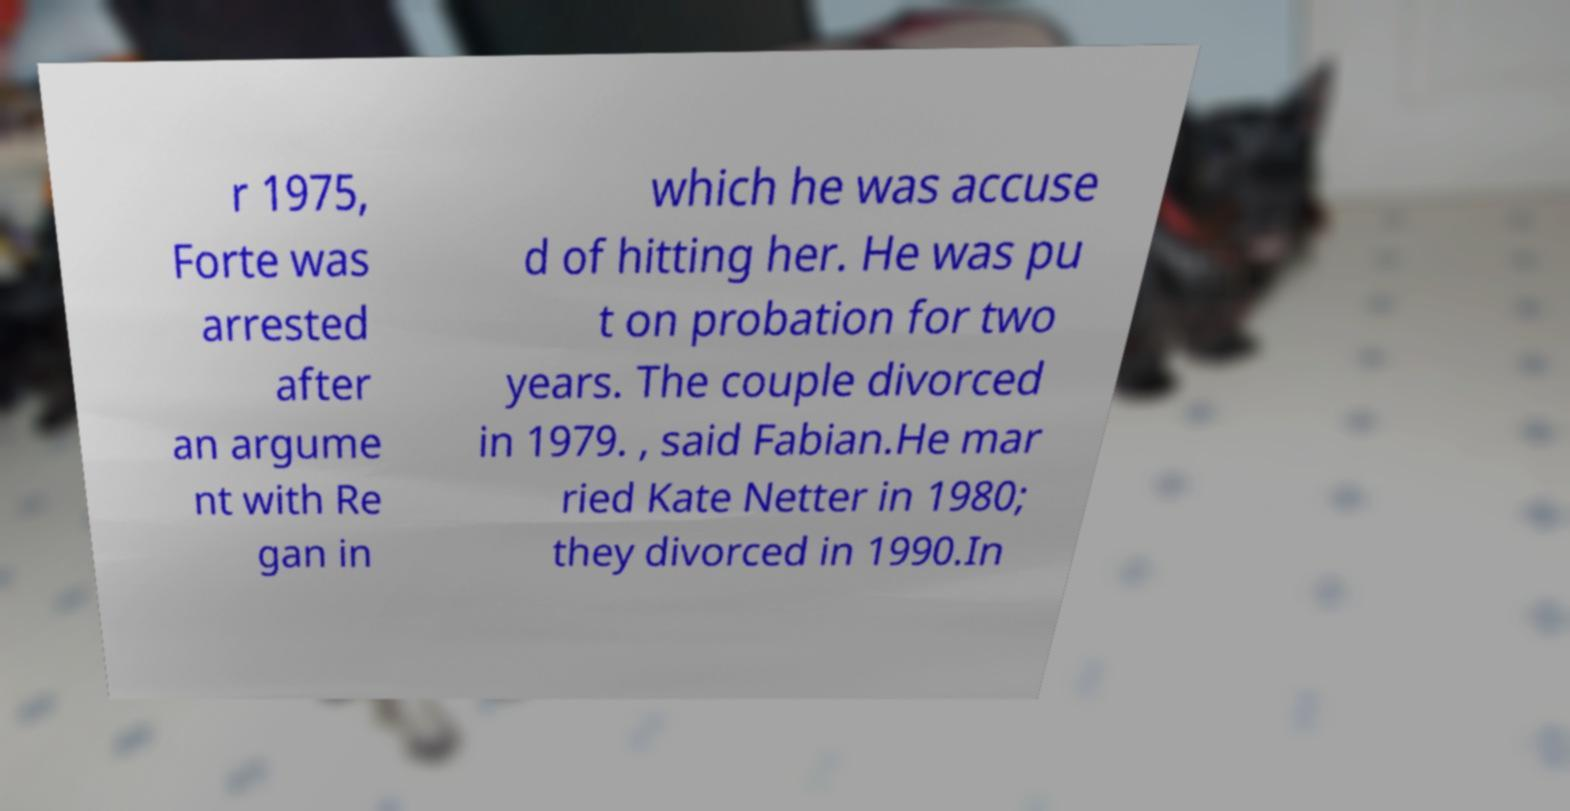What messages or text are displayed in this image? I need them in a readable, typed format. r 1975, Forte was arrested after an argume nt with Re gan in which he was accuse d of hitting her. He was pu t on probation for two years. The couple divorced in 1979. , said Fabian.He mar ried Kate Netter in 1980; they divorced in 1990.In 